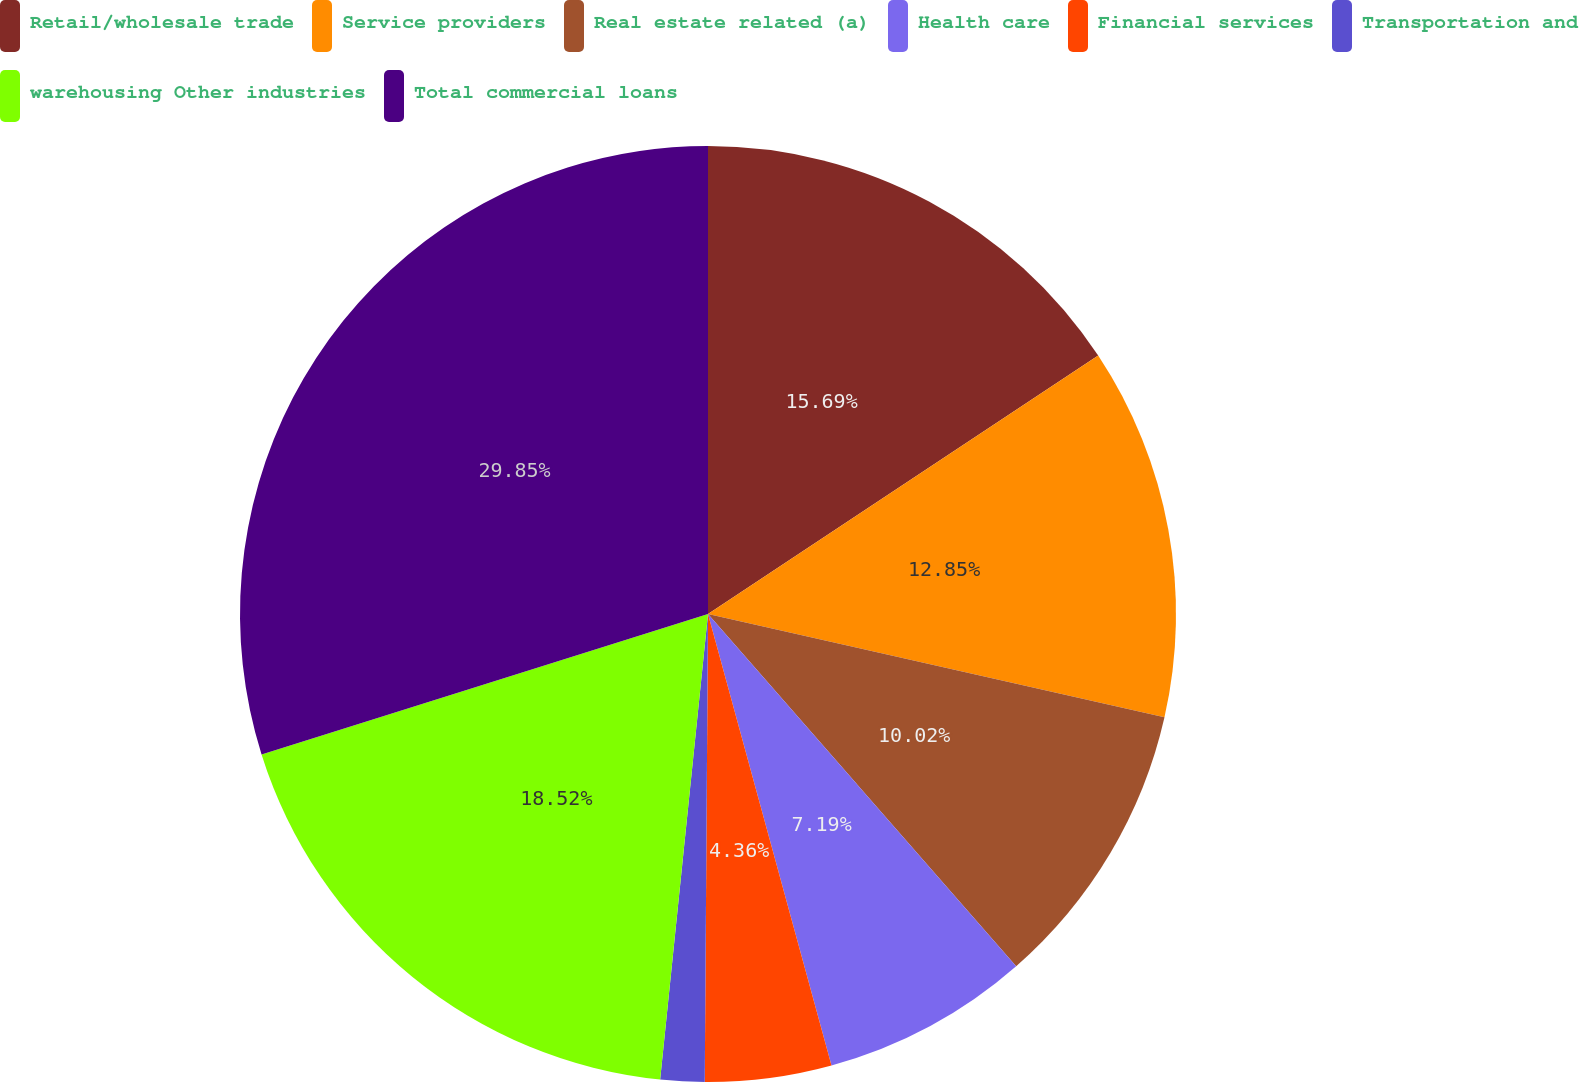Convert chart. <chart><loc_0><loc_0><loc_500><loc_500><pie_chart><fcel>Retail/wholesale trade<fcel>Service providers<fcel>Real estate related (a)<fcel>Health care<fcel>Financial services<fcel>Transportation and<fcel>warehousing Other industries<fcel>Total commercial loans<nl><fcel>15.69%<fcel>12.85%<fcel>10.02%<fcel>7.19%<fcel>4.36%<fcel>1.52%<fcel>18.52%<fcel>29.85%<nl></chart> 